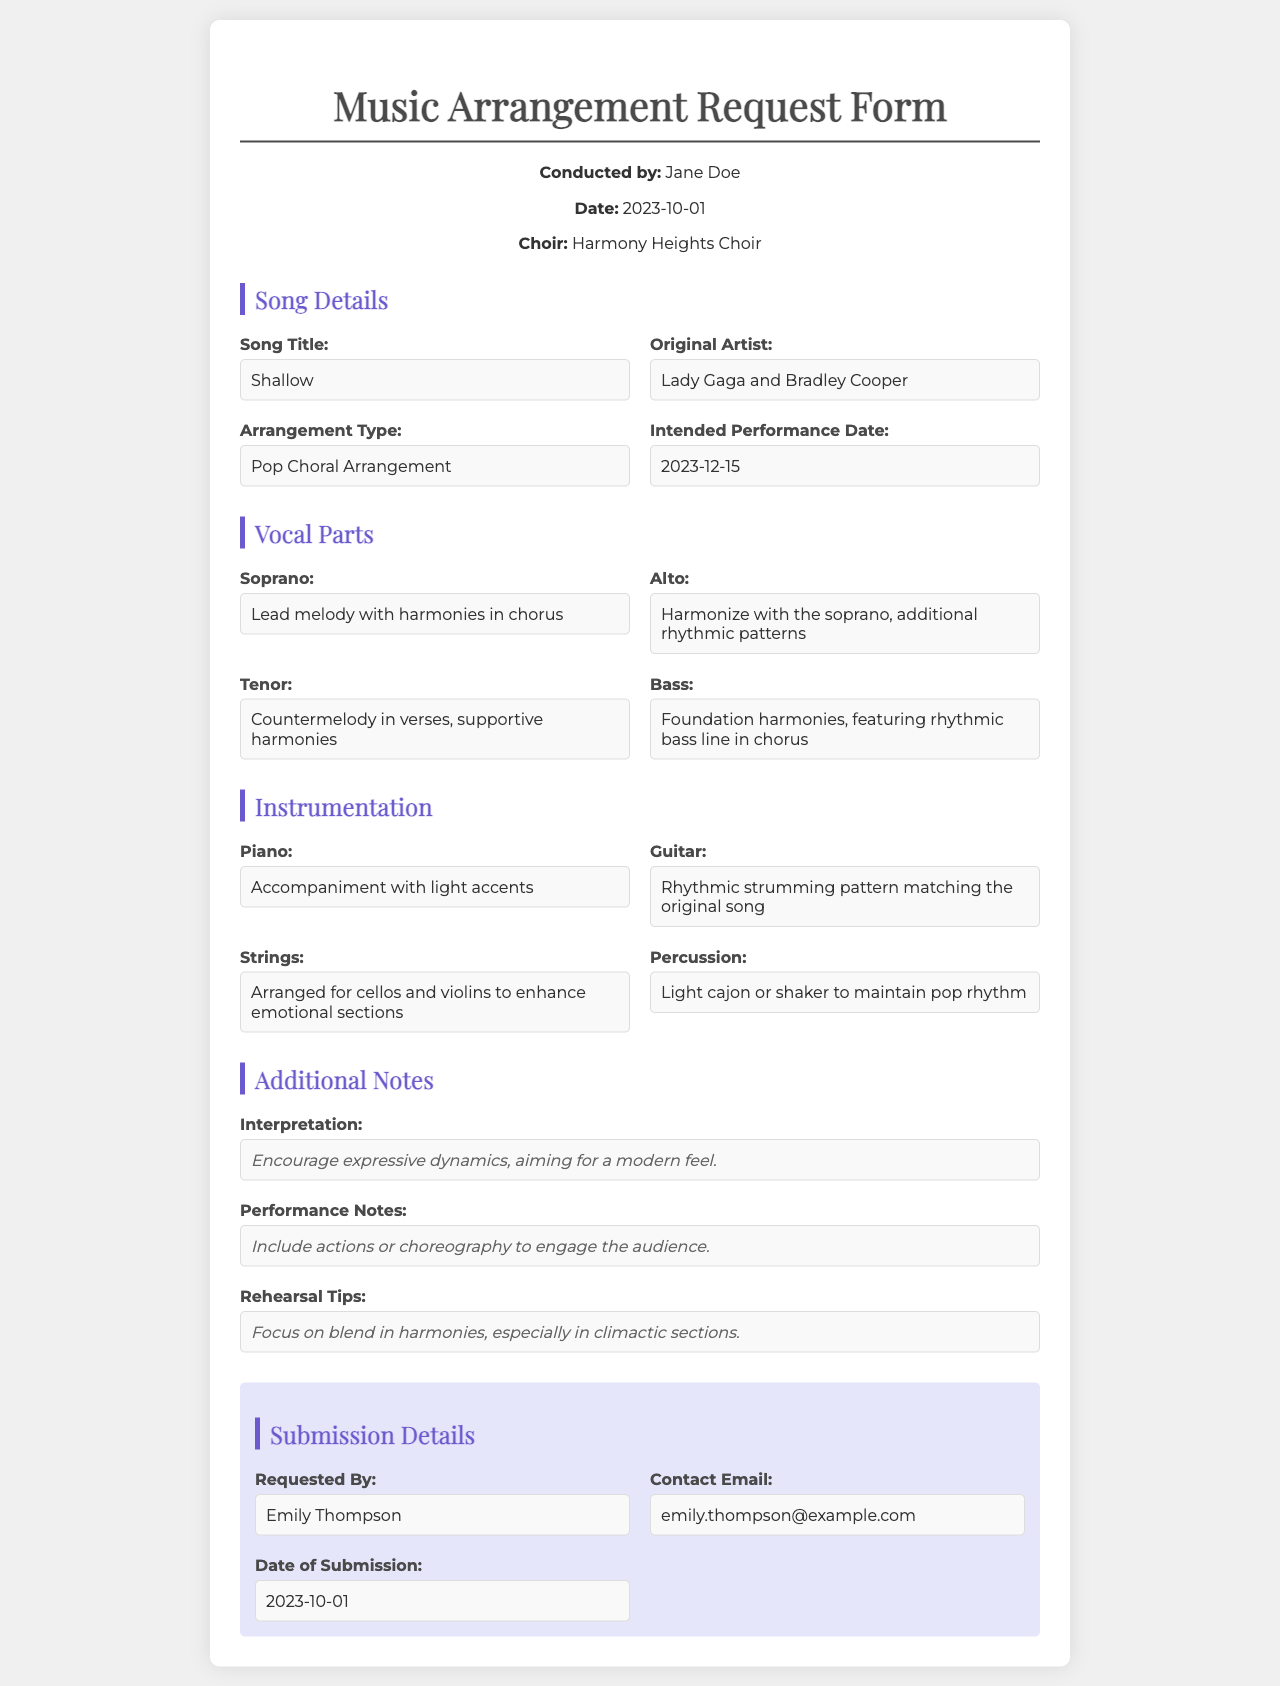What is the song title? The song title is specified in the "Song Details" section of the document.
Answer: Shallow Who is the original artist? The original artist is listed in the "Song Details" section.
Answer: Lady Gaga and Bradley Cooper What is the intended performance date? The intended performance date is found under the "Song Details" section.
Answer: 2023-12-15 What vocal part has the lead melody? The vocal part with the lead melody is described in the "Vocal Parts" section.
Answer: Soprano What instrumentation is used for rhythmic patterns? The instrumentation with rhythmic patterns is mentioned in the "Instrumentation" section.
Answer: Guitar What does the arrangement type specify? The arrangement type indicates the genre or style of the arrangement in the document.
Answer: Pop Choral Arrangement What are the performance notes focused on? The performance notes describe what to include during the performance to enhance audience engagement.
Answer: Actions or choreography Who requested the arrangement? The person who requested the arrangement is identified in the "Submission Details" section.
Answer: Emily Thompson What is suggested for rehearsal tips? The rehearsal tips provide guidance on what to focus on during practice sessions.
Answer: Blend in harmonies 